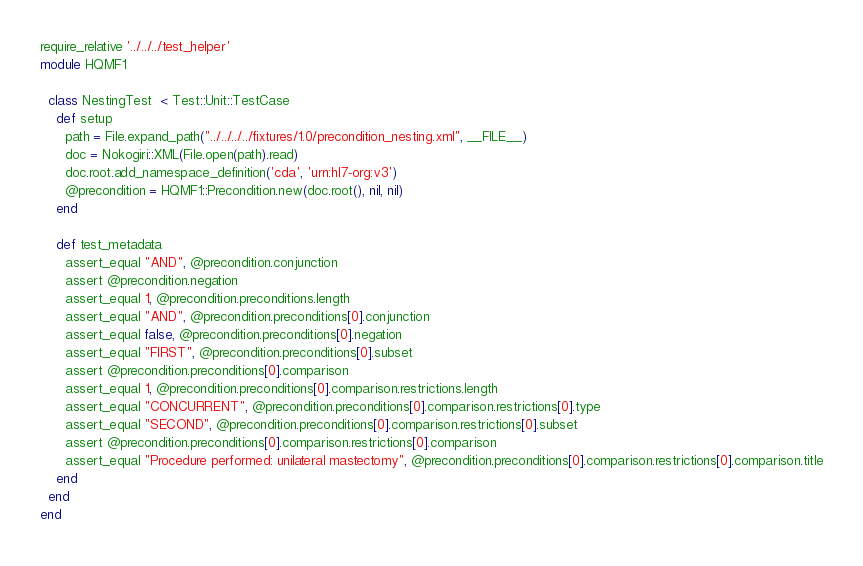<code> <loc_0><loc_0><loc_500><loc_500><_Ruby_>require_relative '../../../test_helper'
module HQMF1

  class NestingTest  < Test::Unit::TestCase
    def setup
      path = File.expand_path("../../../../fixtures/1.0/precondition_nesting.xml", __FILE__)
      doc = Nokogiri::XML(File.open(path).read)
      doc.root.add_namespace_definition('cda', 'urn:hl7-org:v3')
      @precondition = HQMF1::Precondition.new(doc.root(), nil, nil)
    end
  
    def test_metadata
      assert_equal "AND", @precondition.conjunction
      assert @precondition.negation
      assert_equal 1, @precondition.preconditions.length
      assert_equal "AND", @precondition.preconditions[0].conjunction
      assert_equal false, @precondition.preconditions[0].negation
      assert_equal "FIRST", @precondition.preconditions[0].subset
      assert @precondition.preconditions[0].comparison
      assert_equal 1, @precondition.preconditions[0].comparison.restrictions.length
      assert_equal "CONCURRENT", @precondition.preconditions[0].comparison.restrictions[0].type
      assert_equal "SECOND", @precondition.preconditions[0].comparison.restrictions[0].subset
      assert @precondition.preconditions[0].comparison.restrictions[0].comparison
      assert_equal "Procedure performed: unilateral mastectomy", @precondition.preconditions[0].comparison.restrictions[0].comparison.title
    end
  end
end
</code> 